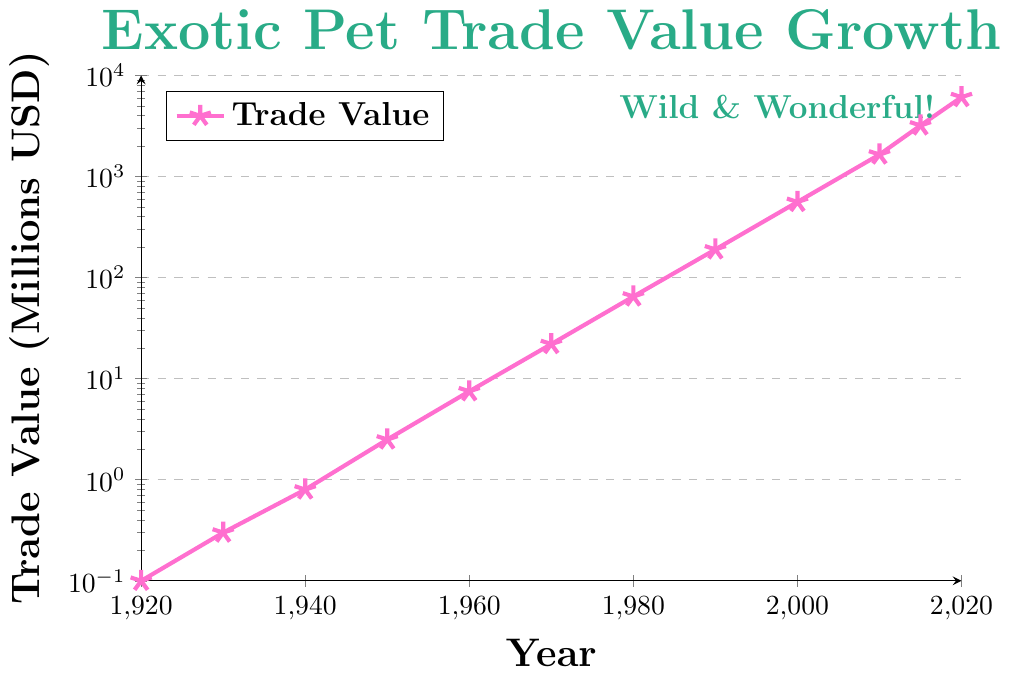When was the trade value the highest? The highest trade value on the graph is in 2020, which is marked at 6100 million USD. Looking at the x-axis (year) corresponding to this peak confirms 2020 as the year.
Answer: 2020 By how much did the trade value increase between 1930 and 1950? From the chart, the trade value in 1930 is 0.3 million USD and in 1950 is 2.5 million USD. The difference is calculated as 2.5 - 0.3 = 2.2 million USD.
Answer: 2.2 million USD Which decade saw the largest increase in trade value? To identify the largest increase, we need to compare the trade values at the start and end of each decade. By visual inspection, the most significant leap appears before 2020, from about 3200 million USD in 2015 to 6100 million USD in 2020.
Answer: 2010s What's the median value of trade figures on the chart? The trade values need to be ordered: 0.1, 0.3, 0.8, 2.5, 7.5, 22, 65, 190, 560, 1650, 3200, 6100. Since there are 12 data points (even number), the median will be the average of the 6th and 7th values, i.e., (22 + 65) / 2 = 43.5 million USD.
Answer: 43.5 million USD In what year did the trade value first exceed 100 million USD? From the graph, it can be observed that the trade value first exceeds 100 million USD in 1980 when it reaches 190 million USD.
Answer: 1980 How many times did the trade value double between 1960 and 2010? The trade value doubled several times between 1960 (7.5 million USD) and 2010 (1650 million USD). The series of doubling values would be 7.5, 15, 30, 60, 120, 240, 480, 960, 1920. During this period, the trade value doubled approximately 7 times (since 1920 exceeds 1650).
Answer: 7 times What is the color of the line indicating the trade value on the graph? The graph has a line that is visually marked in a bright pink color, symbolizing the trade values over the years.
Answer: pink From 2000 to 2020, by what factor did the trade value increase? The value in 2000 was 560 million USD, and in 2020 it was 6100 million USD. The factor of increase is calculated by dividing the 2020 value by the 2000 value: 6100 / 560 ≈ 10.89.
Answer: ≈10.89 Between which two consecutive years was the smallest increase in trade value observed? The smallest increase can be quickly visualized between 1940 (0.8 million USD) and 1950 (2.5 million USD) as opposed to later years where differences appear larger. The increase here is only 1.7 million USD.
Answer: 1940 and 1950 Identify the year when the trade value was closest to 1000 million USD. From the visual inspection, the trade value in 2010 is closest to 1000 million USD, with a value of 1650 million USD.
Answer: 2010 